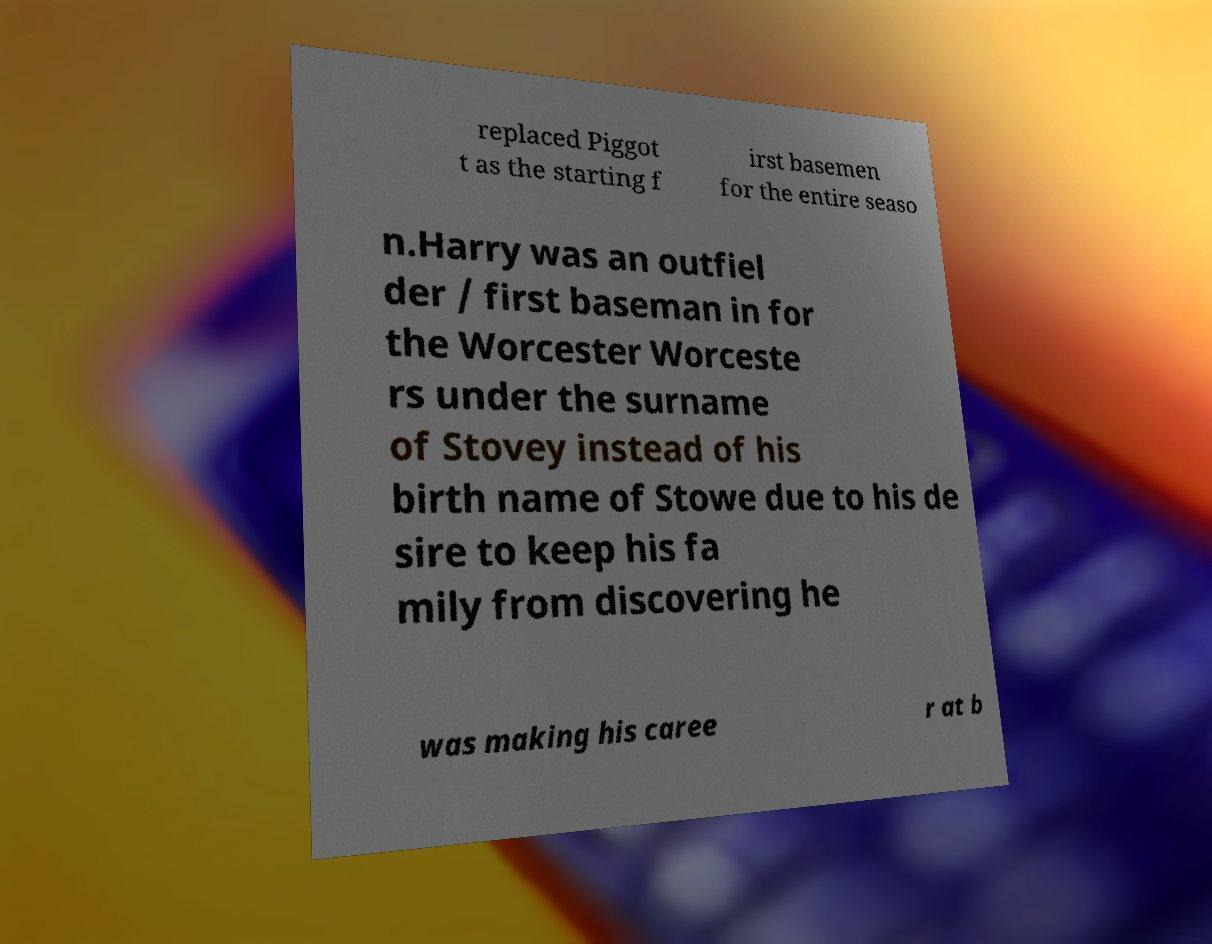Please identify and transcribe the text found in this image. replaced Piggot t as the starting f irst basemen for the entire seaso n.Harry was an outfiel der / first baseman in for the Worcester Worceste rs under the surname of Stovey instead of his birth name of Stowe due to his de sire to keep his fa mily from discovering he was making his caree r at b 